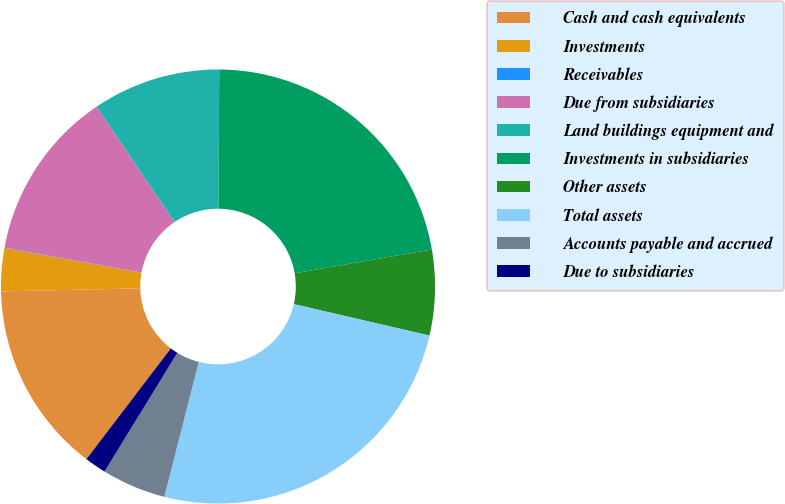Convert chart to OTSL. <chart><loc_0><loc_0><loc_500><loc_500><pie_chart><fcel>Cash and cash equivalents<fcel>Investments<fcel>Receivables<fcel>Due from subsidiaries<fcel>Land buildings equipment and<fcel>Investments in subsidiaries<fcel>Other assets<fcel>Total assets<fcel>Accounts payable and accrued<fcel>Due to subsidiaries<nl><fcel>14.27%<fcel>3.2%<fcel>0.03%<fcel>12.69%<fcel>9.53%<fcel>22.18%<fcel>6.36%<fcel>25.35%<fcel>4.78%<fcel>1.61%<nl></chart> 